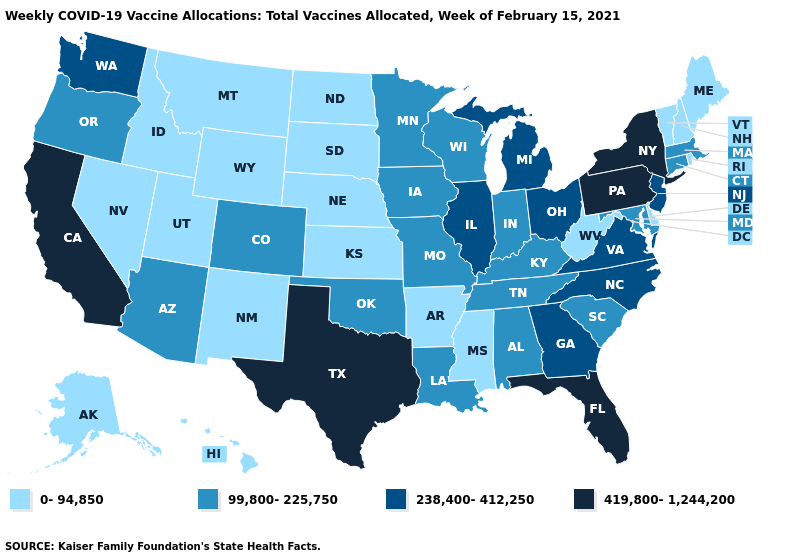Does West Virginia have the lowest value in the South?
Keep it brief. Yes. Name the states that have a value in the range 419,800-1,244,200?
Be succinct. California, Florida, New York, Pennsylvania, Texas. What is the highest value in the USA?
Keep it brief. 419,800-1,244,200. Does Maine have the same value as Nebraska?
Keep it brief. Yes. Name the states that have a value in the range 0-94,850?
Quick response, please. Alaska, Arkansas, Delaware, Hawaii, Idaho, Kansas, Maine, Mississippi, Montana, Nebraska, Nevada, New Hampshire, New Mexico, North Dakota, Rhode Island, South Dakota, Utah, Vermont, West Virginia, Wyoming. Which states hav the highest value in the MidWest?
Be succinct. Illinois, Michigan, Ohio. What is the lowest value in the West?
Concise answer only. 0-94,850. Among the states that border New Mexico , which have the highest value?
Short answer required. Texas. What is the value of Hawaii?
Keep it brief. 0-94,850. Does California have the highest value in the West?
Concise answer only. Yes. What is the lowest value in states that border Louisiana?
Answer briefly. 0-94,850. What is the value of Oklahoma?
Answer briefly. 99,800-225,750. Among the states that border Missouri , does Illinois have the highest value?
Give a very brief answer. Yes. 